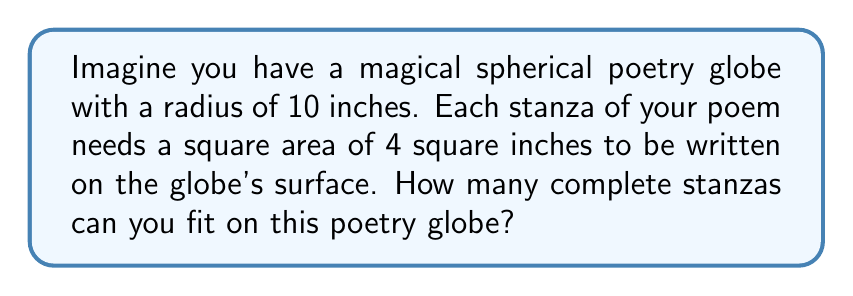Solve this math problem. Let's approach this step-by-step:

1) First, we need to calculate the surface area of the sphere. The formula for the surface area of a sphere is:

   $$ A = 4\pi r^2 $$

   Where $r$ is the radius of the sphere.

2) Given that the radius is 10 inches, we can calculate:

   $$ A = 4\pi (10)^2 = 400\pi \approx 1256.64 \text{ square inches} $$

3) Now, each stanza requires a square area of 4 square inches. To find how many stanzas can fit, we divide the total surface area by the area needed for each stanza:

   $$ \text{Number of stanzas} = \frac{\text{Surface area of sphere}}{\text{Area per stanza}} $$

   $$ \text{Number of stanzas} = \frac{400\pi}{4} = 100\pi \approx 314.16 $$

4) Since we can only have whole stanzas, we need to round down to the nearest integer.

[asy]
import geometry;

size(100);
draw(circle((0,0),5));
label("Poetry Globe", (0,0), fontsize(10));
label("r = 10 inches", (5,0), E, fontsize(8));
draw((5,0)--(7,0), Arrow);
[/asy]
Answer: 314 stanzas 